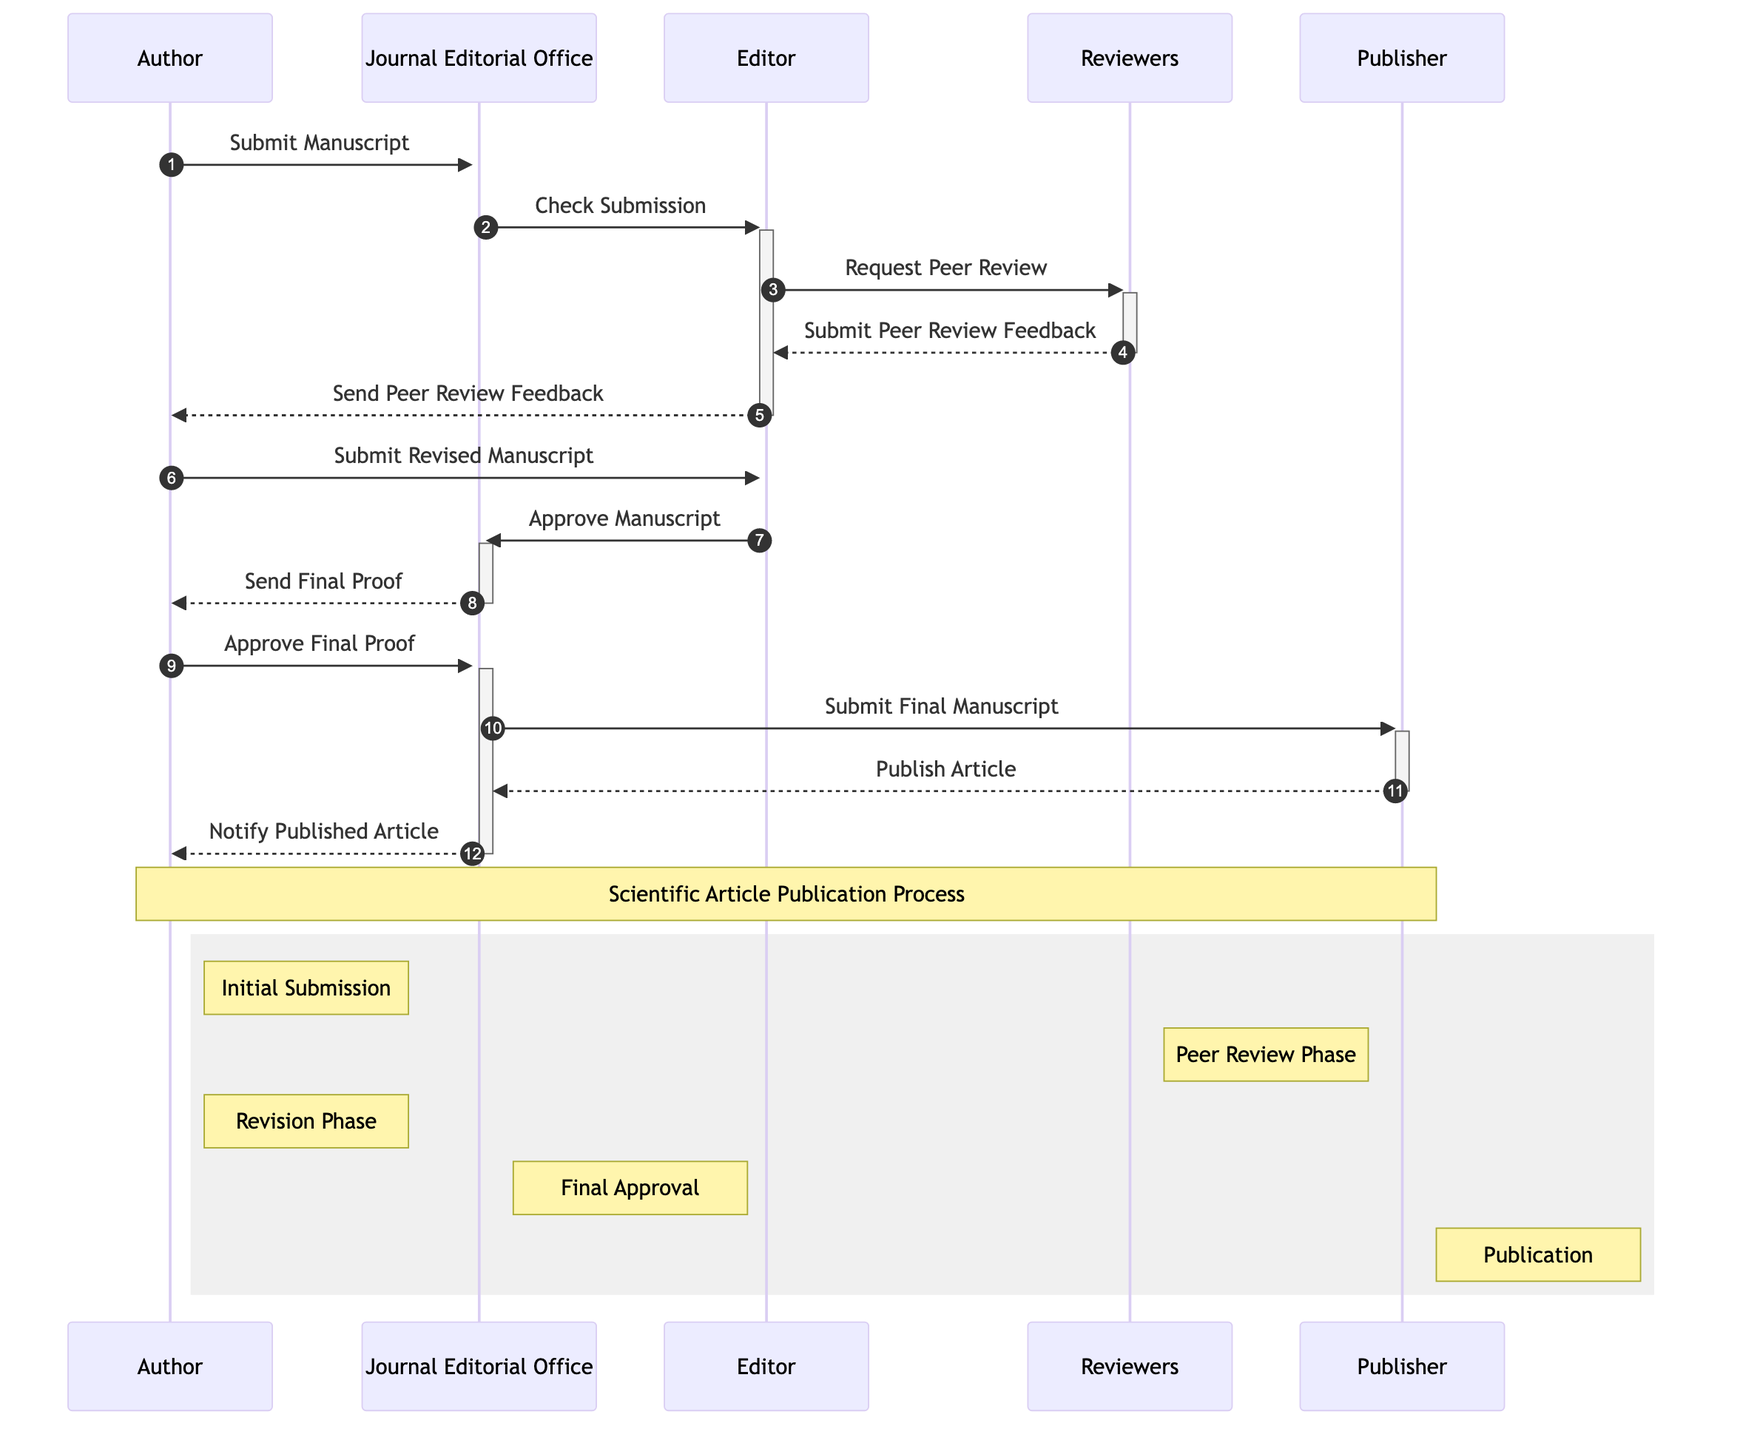What is the first action taken in the publication process? The first action in the sequence diagram is the "Submit Manuscript," which is initiated by the Author to the Journal Editorial Office.
Answer: Submit Manuscript How many different actors are involved in the process? The diagram lists five different actors involved in the publication process: Author, Journal Editorial Office, Editor, Reviewers, and Publisher.
Answer: Five What message does the Journal Editorial Office send to the Editor? The Journal Editorial Office sends the message "Check Submission" to the Editor after receiving the Manuscript from the Author.
Answer: Check Submission Who sends the "Send Peer Review Feedback" message? The Editor sends the "Send Peer Review Feedback" message to the Author after receiving the Peer Review Feedback from the Reviewers.
Answer: Editor What feedback does the Author submit after receiving feedback from the Editor? After receiving feedback from the Editor, the Author submits a "Revised Manuscript" in response to the comments and suggestions provided.
Answer: Revised Manuscript What message is sent before the publication of the article? Before the publication of the article, the Journal Editorial Office sends the message "Submit Final Manuscript" to the Publisher, signifying the final step prior to publication.
Answer: Submit Final Manuscript In which phase does the Author interact with the Reviewers? The Author interacts with the Reviewers during the "Peer Review Phase," where Reviewers provide feedback to the Editor, which is then relayed to the Author.
Answer: Peer Review Phase How many messages are exchanged between the Author and the Journal Editorial Office? There are four messages exchanged between the Author and the Journal Editorial Office throughout the process, specifically regarding the manuscript submission, final proof, and notification of the published article.
Answer: Four What is the final outcome conveyed to the Author? The final outcome conveyed to the Author is the "Notify Published Article," which indicates that the article has been officially published after completing all prior steps.
Answer: Notify Published Article 